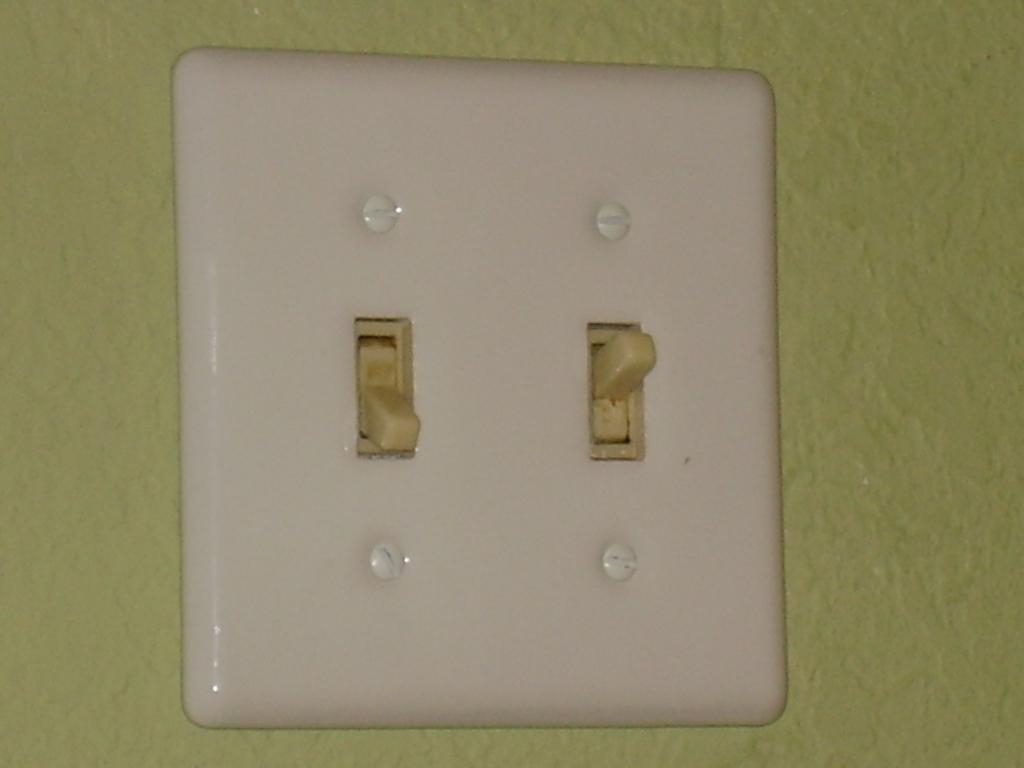What is located on the wall in the image? There is a switch board on the wall in the image. What might the switch board be used for? The switch board is likely used for controlling electrical devices or circuits. What type of air can be seen coming out of the switch board in the image? There is no air coming out of the switch board in the image, as it is an electrical device and not a source of air. 